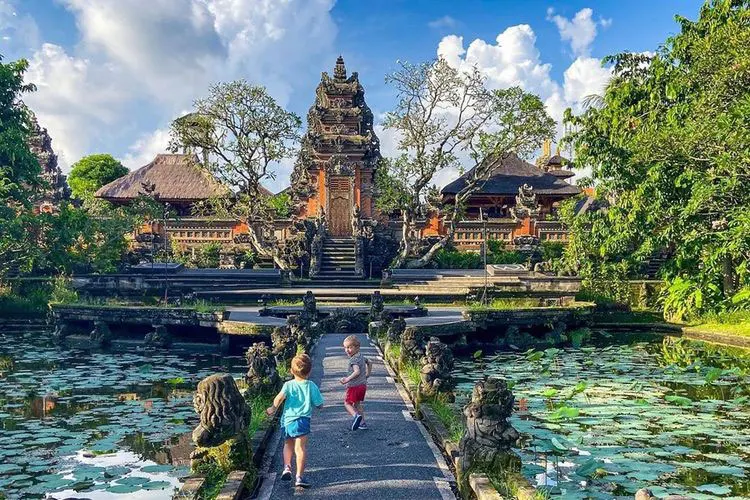Imagine the future of this place. What might it look like in 100 years? In 100 years, the Ubud Water Palace might have evolved while preserving its historical essence. Advanced preservation techniques could maintain its current grandeur, while modern enhancements might integrate seamlessly, such as discreet lighting accentuating the carvings at night. The gardens could transform with even richer biodiversity, combining native flora with rare botanical specimens introduced from around the globe, creating a living tapestry of colors and textures. The pond could be equipped with eco-friendly water filtration systems, preserving its pristine condition. Technological advancements might offer virtual tours, augmented reality experiences, and cultural programs, allowing global audiences to explore the palace's history and beauty from anywhere in the world. 